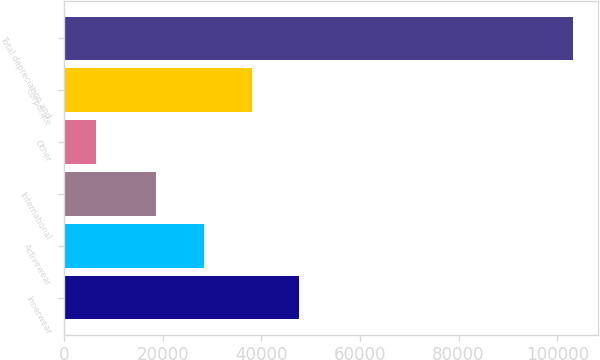<chart> <loc_0><loc_0><loc_500><loc_500><bar_chart><fcel>Innerwear<fcel>Activewear<fcel>International<fcel>Other<fcel>Corporate<fcel>Total depreciation and<nl><fcel>47673.7<fcel>28353.9<fcel>18694<fcel>6576<fcel>38013.8<fcel>103175<nl></chart> 